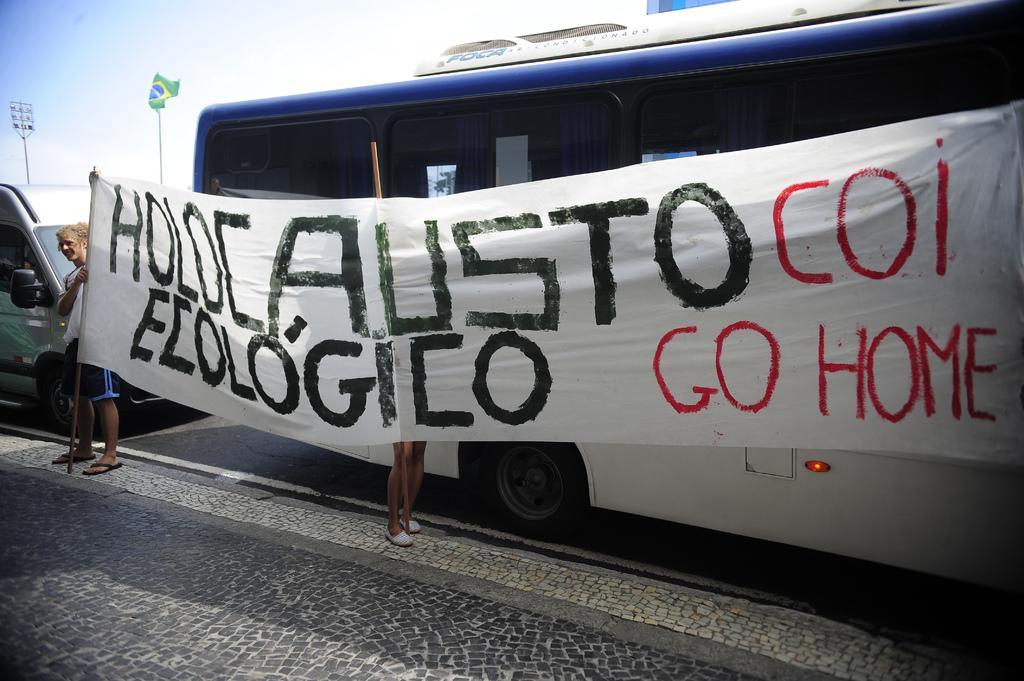Can you describe this image briefly? In this image we can see a bus and a truck on the road. We can also see two people holding a banner with the sticks on the footpath. On the backside we can see a flag to a pole, lights and the sky which looks cloudy. 